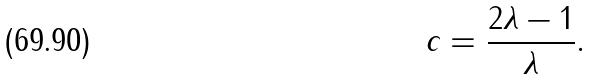<formula> <loc_0><loc_0><loc_500><loc_500>c = \frac { 2 \lambda - 1 } { \lambda } .</formula> 